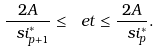<formula> <loc_0><loc_0><loc_500><loc_500>\frac { 2 A } { \ s i ^ { * } _ { p + 1 } } \leq \ e t \leq \frac { 2 A } { \ s i ^ { * } _ { p } } .</formula> 